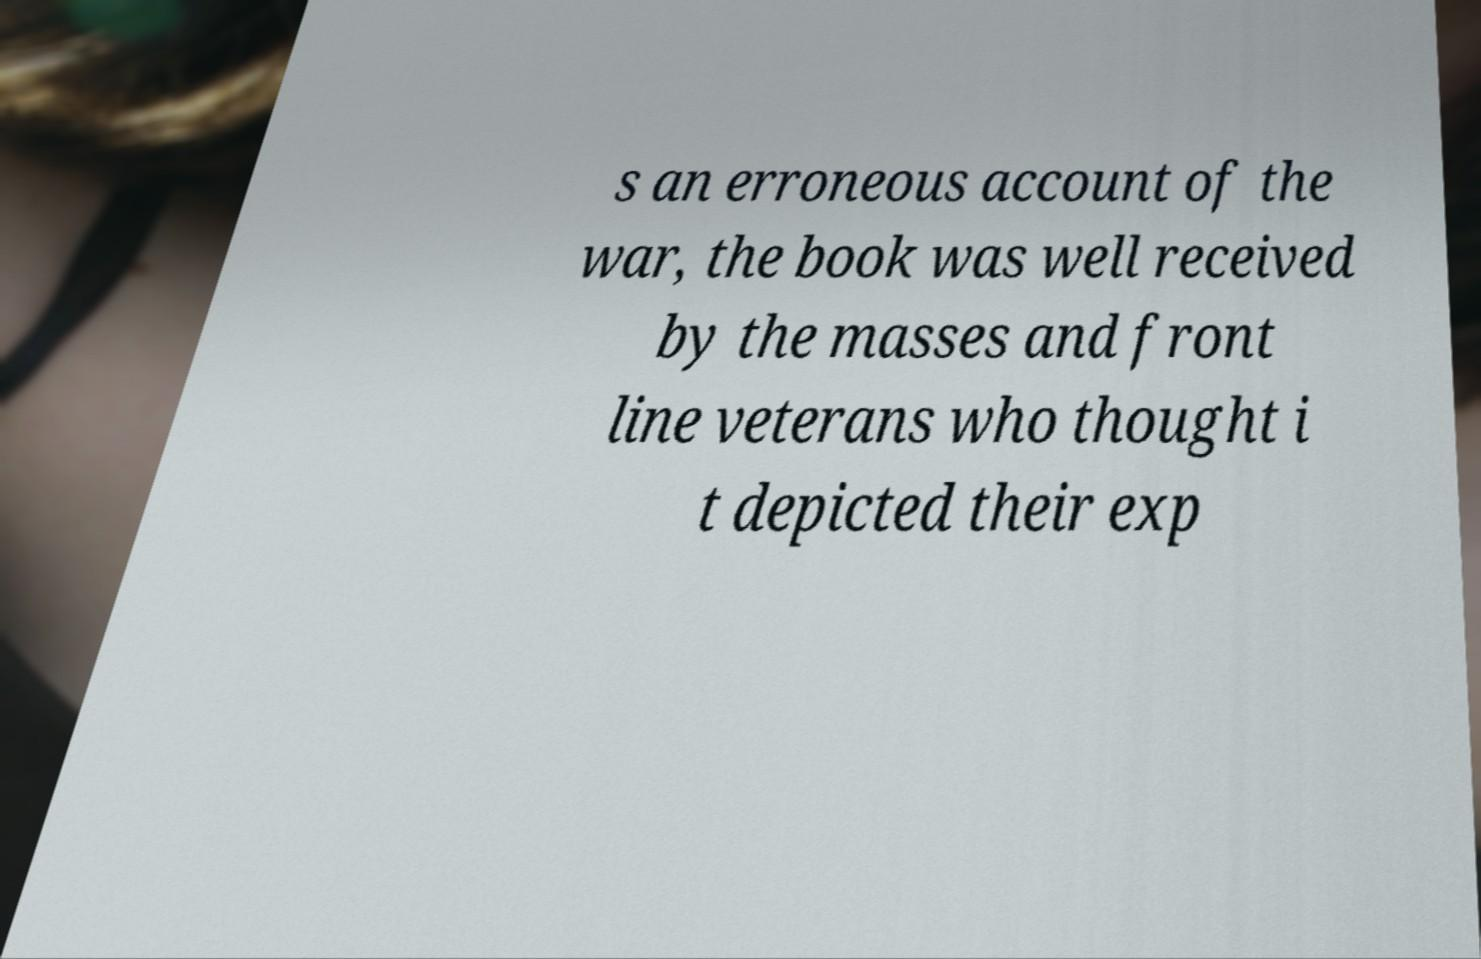What messages or text are displayed in this image? I need them in a readable, typed format. s an erroneous account of the war, the book was well received by the masses and front line veterans who thought i t depicted their exp 